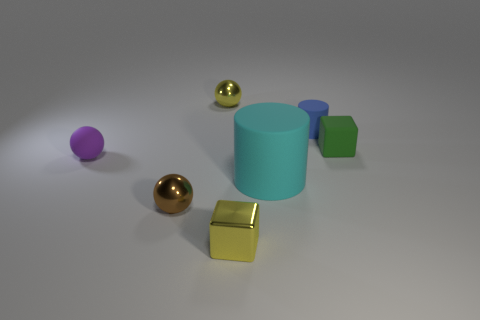There is a green cube that is the same size as the matte ball; what material is it?
Your answer should be compact. Rubber. There is a green object that is the same size as the yellow metallic block; what is its shape?
Your answer should be compact. Cube. There is a purple matte thing; how many things are behind it?
Provide a short and direct response. 3. Does the purple sphere have the same material as the cylinder that is behind the rubber sphere?
Your answer should be compact. Yes. Is the material of the cyan object the same as the blue thing?
Provide a succinct answer. Yes. Is there a object in front of the yellow object that is behind the purple rubber object?
Your answer should be compact. Yes. How many small blocks are in front of the brown metallic sphere and behind the large rubber cylinder?
Ensure brevity in your answer.  0. There is a yellow metal object that is behind the purple rubber sphere; what is its shape?
Your response must be concise. Sphere. How many brown balls have the same size as the blue thing?
Keep it short and to the point. 1. There is a metallic ball in front of the large rubber cylinder; is its color the same as the matte sphere?
Offer a terse response. No. 